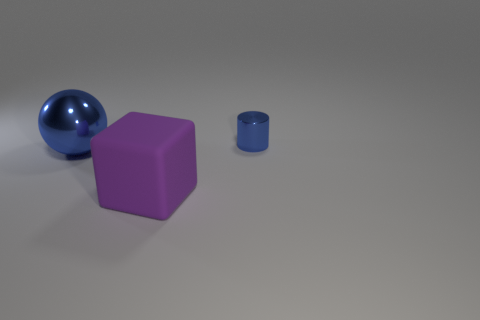How many other objects are there of the same shape as the big purple object?
Offer a terse response. 0. Does the purple rubber thing have the same shape as the big blue thing?
Provide a short and direct response. No. Are there any purple matte things in front of the blue metal cylinder?
Offer a terse response. Yes. How many things are blue cylinders or small cyan matte things?
Make the answer very short. 1. How many other things are the same size as the rubber thing?
Keep it short and to the point. 1. How many things are left of the tiny blue shiny cylinder and to the right of the large blue ball?
Give a very brief answer. 1. Is the size of the object that is behind the blue metallic sphere the same as the shiny thing that is on the left side of the large matte cube?
Provide a short and direct response. No. There is a blue thing that is on the left side of the tiny cylinder; how big is it?
Offer a terse response. Large. What number of objects are things that are to the right of the big rubber thing or things behind the large purple cube?
Offer a terse response. 2. Is there any other thing that has the same color as the block?
Provide a short and direct response. No. 